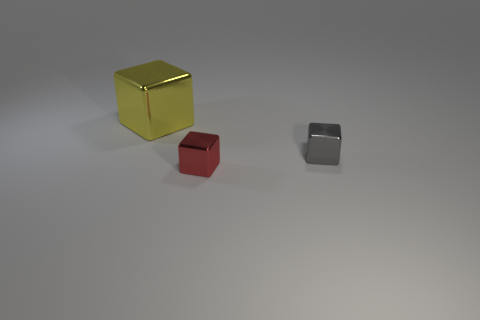Add 2 rubber cylinders. How many objects exist? 5 Add 1 tiny cubes. How many tiny cubes are left? 3 Add 2 tiny red rubber objects. How many tiny red rubber objects exist? 2 Subtract 0 yellow spheres. How many objects are left? 3 Subtract all tiny blue cylinders. Subtract all cubes. How many objects are left? 0 